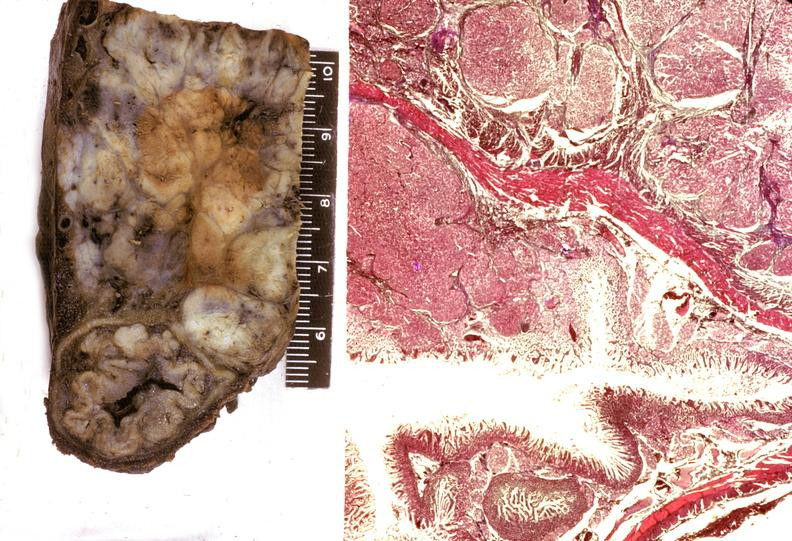does this image show islet cell carcinoma?
Answer the question using a single word or phrase. Yes 